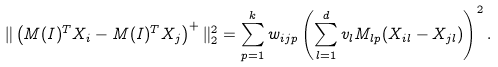Convert formula to latex. <formula><loc_0><loc_0><loc_500><loc_500>\| \left ( M ( I ) ^ { T } X _ { i } - M ( I ) ^ { T } X _ { j } \right ) ^ { + } \| _ { 2 } ^ { 2 } & = \sum _ { p = 1 } ^ { k } w _ { i j p } \left ( \sum _ { l = 1 } ^ { d } v _ { l } M _ { l p } ( X _ { i l } - X _ { j l } ) \right ) ^ { 2 } .</formula> 